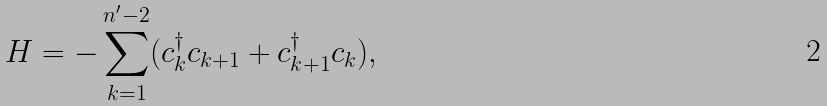<formula> <loc_0><loc_0><loc_500><loc_500>H = - \sum _ { k = 1 } ^ { n ^ { \prime } - 2 } ( c _ { k } ^ { \dag } c _ { k + 1 } + c _ { k + 1 } ^ { \dag } c _ { k } ) ,</formula> 